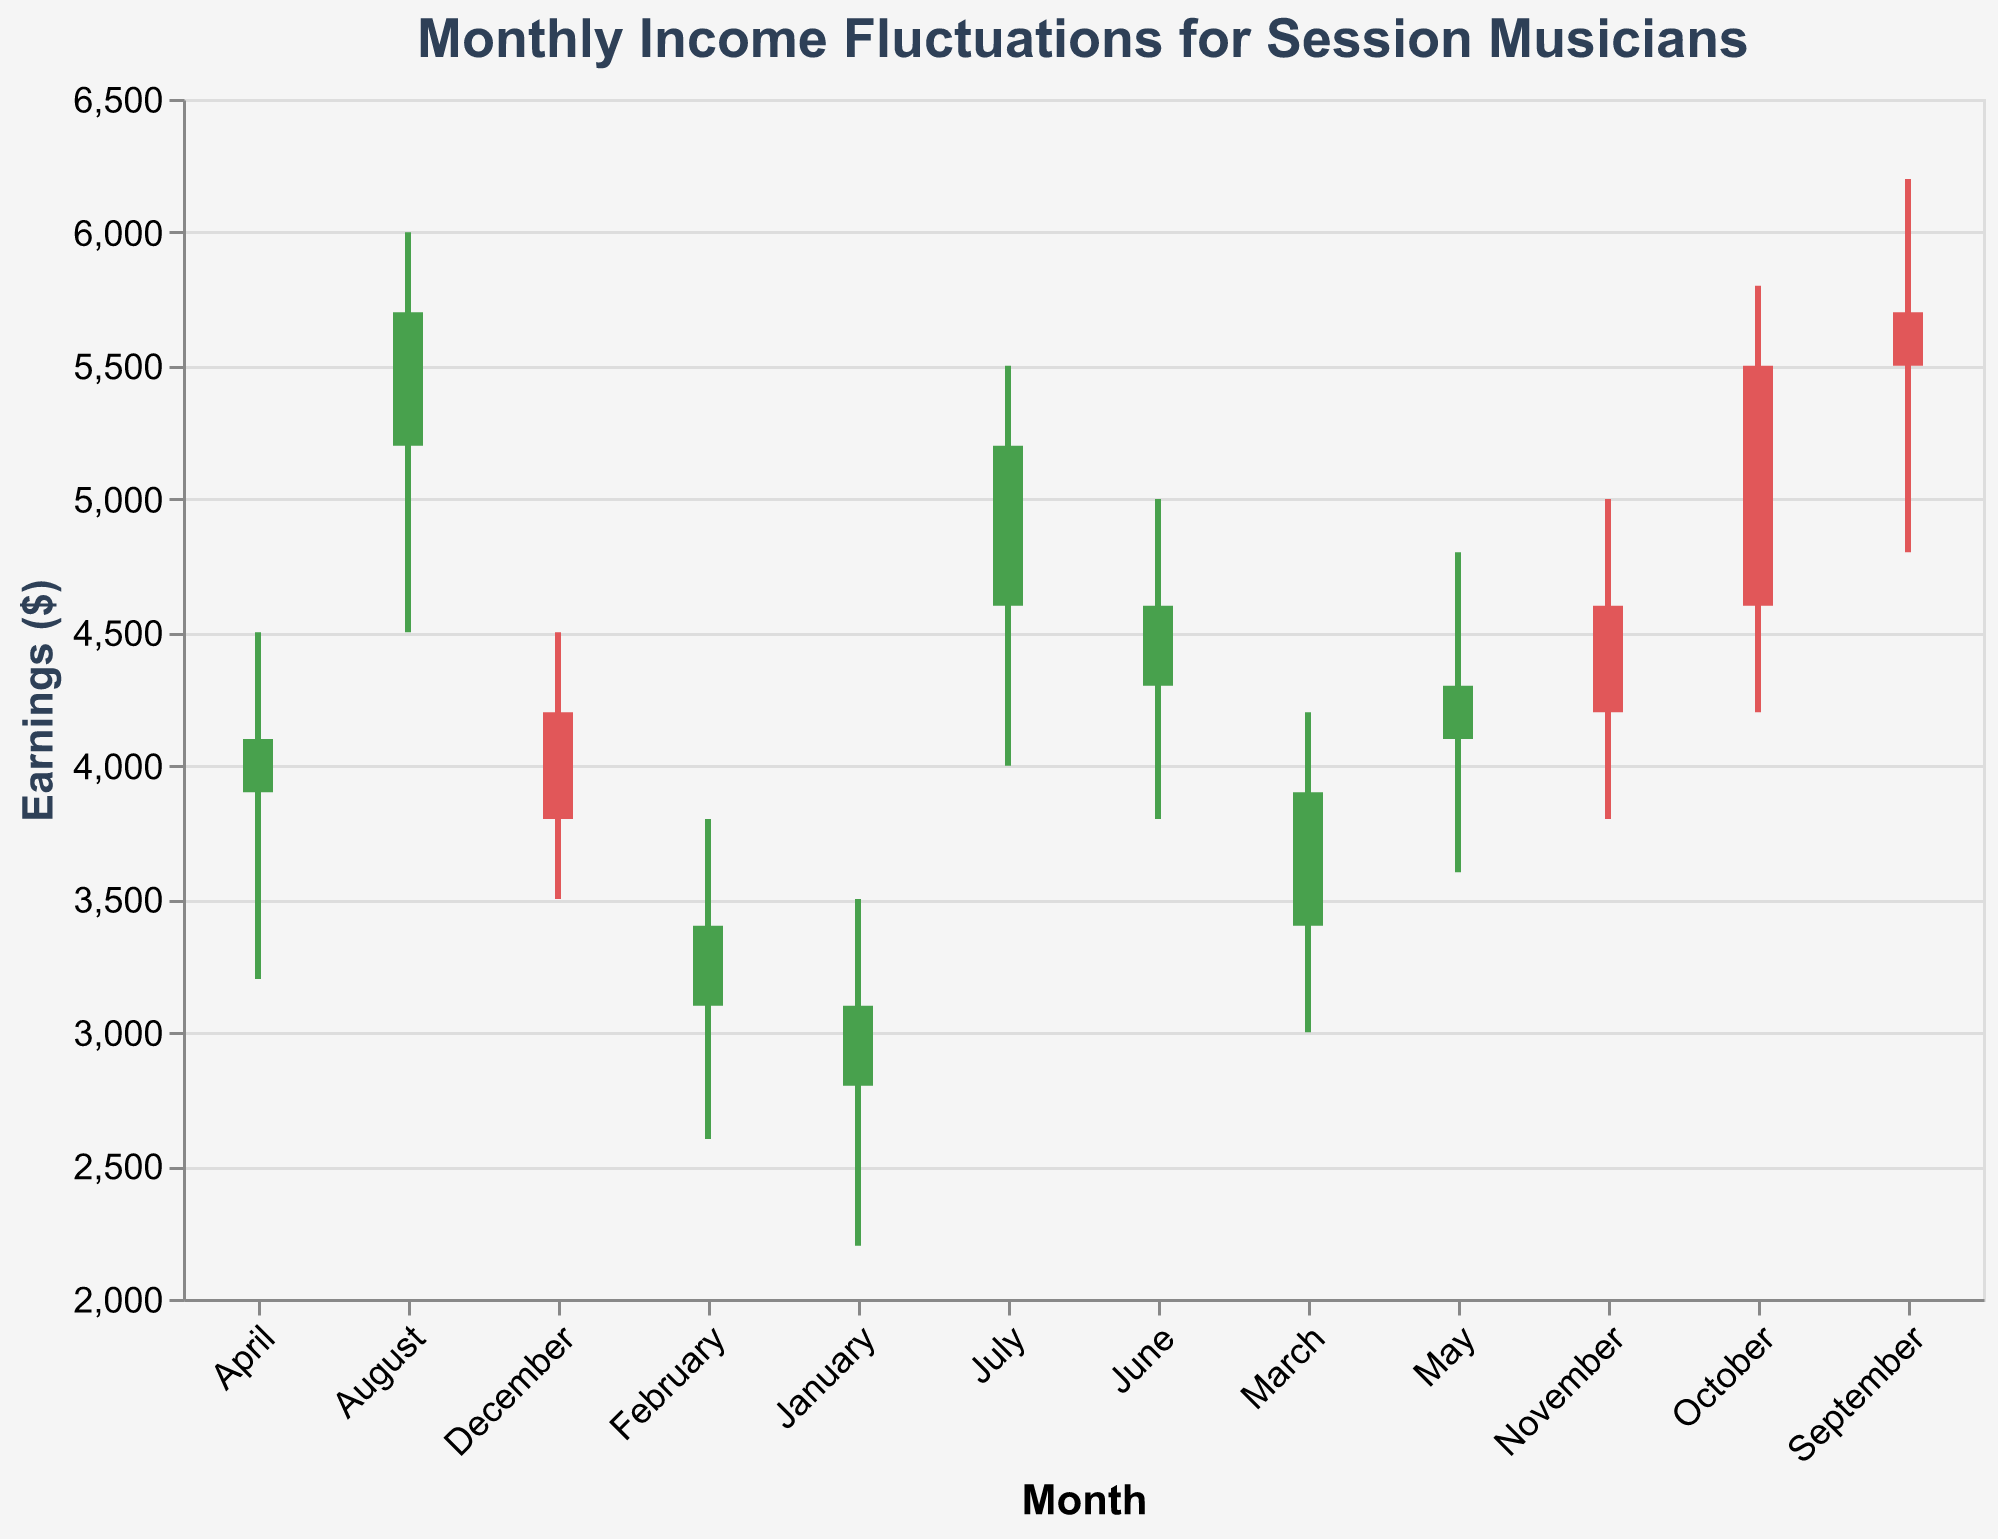What's the title of the figure? The title is always placed at the top of the chart and clearly indicates what the chart is about.
Answer: Monthly Income Fluctuations for Session Musicians How many months show an increase in income from the opening to the closing? By observing the color of the bars which indicates the month where the closing is higher than the opening, we can count the green bars.
Answer: 8 What is the highest earnings value (High) in any month? By looking at the upper limit of the vertical rule for each month, the highest point marked is in August.
Answer: 6000 Which month experienced the smallest fluctuation in earnings, and what was the range? Fluctuation can be assessed by subtracting the Low from the High for each month. The smallest difference is for October (5800-4200).
Answer: October, 1600 Which month opened with the highest earnings, and what was the value? The opening value is represented at the bottom of the vertical bar; the highest opening is in September.
Answer: September, 5700 During which month did the income drop from opening to closing, and what was the closing value? Red bars indicate months where income fell from opening to closing. Examining these shows December with an opening of 4200 and closing at 3800.
Answer: December, 3800 What is the average closing income over the year? Sum all closing values and divide by 12: (3100 + 3400 + 3900 + 4100 + 4300 + 4600 + 5200 + 5700 + 5500 + 4600 + 4200 + 3800) / 12.
Answer: 4358 Which month showed the highest increase in income between its open and close values? Increase determined by the highest positive difference between opening and closing values. July shows an increase from 4600 to 5200, a difference of 600.
Answer: July Compare the earnings fluctuation in January to that in August. Which month had greater variation? Variation is the difference between High and Low. In January, it is (3500 - 2200 = 1300), and in August, it is (6000 - 4500 = 1500).
Answer: August During which month did income drop to the lowest point, and what was that value? The Low value is marked at the lowest tip of the vertical rule. The lowest point occurs in January.
Answer: January, 2200 